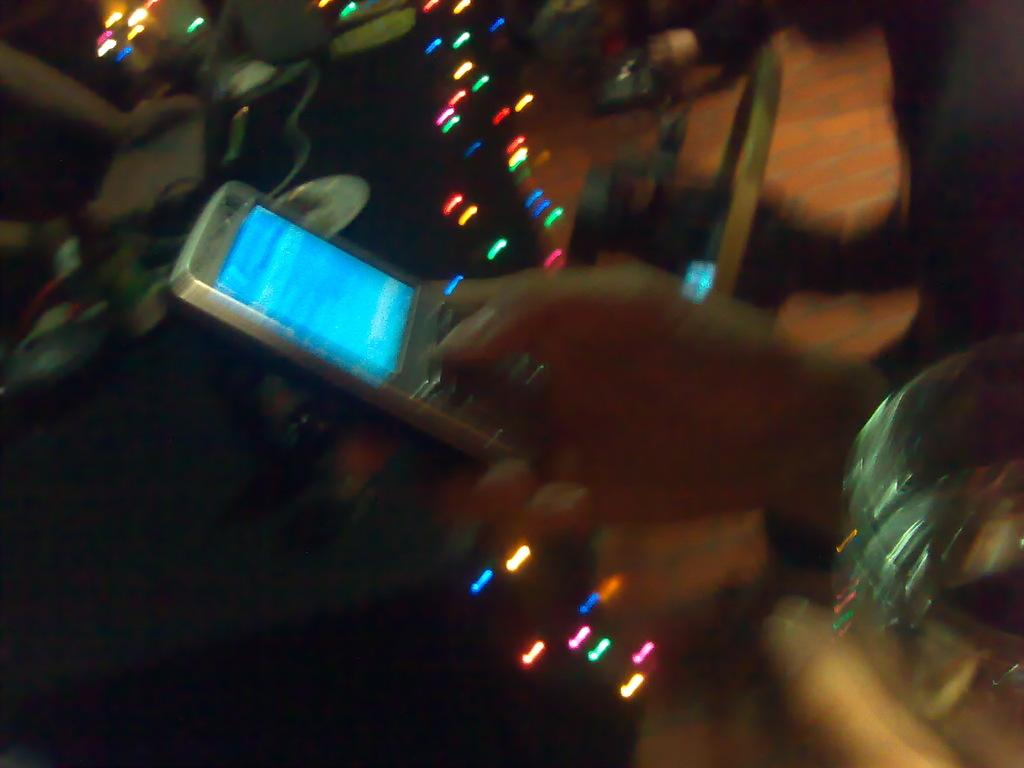What is the person in the image holding? The person is holding an object in the image. Can you describe the other objects in the image? There are many objects in the image, but their specific details are not mentioned in the facts. How many lights can be seen in the image? There are a few lights in the image. What is the appearance of the background in the image? The background of the image is blurred. What type of music can be heard playing in the background of the image? There is no information about music or sound in the image, so it cannot be determined from the facts. 